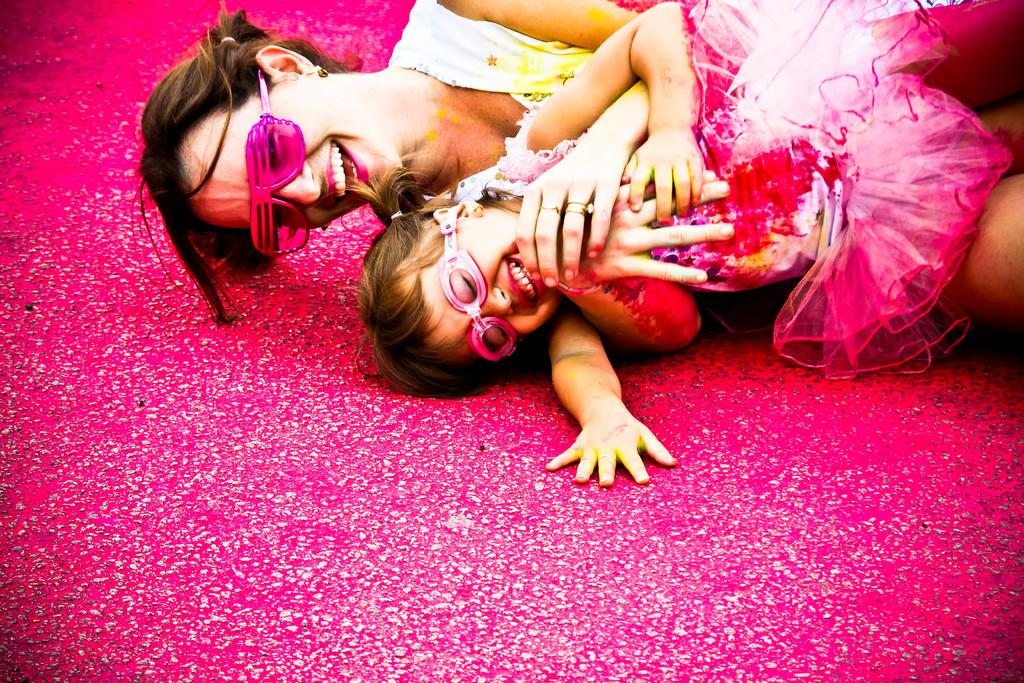Who is present in the picture with the small girl? There is a mother present in the picture with the small girl. What is the small girl wearing that is pink in color? The small girl is wearing pink color glasses. What is the facial expression of the small girl? The small girl is smiling. What position are the mother and the small girl in? The mother and the small girl are lying on the ground. What can be seen on the road in the front bottom side of the image? There is a pink color on the road in the front bottom side of the image. What type of potato is being used for scientific experiments in the image? There is no potato or scientific experiment present in the image. 